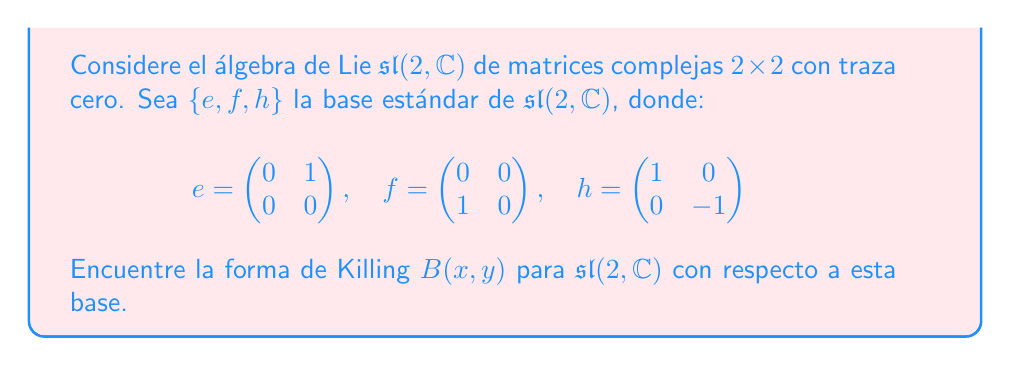Provide a solution to this math problem. Para encontrar la forma de Killing de $\mathfrak{sl}(2, \mathbb{C})$, seguiremos estos pasos:

1) La forma de Killing se define como $B(x,y) = \text{tr}(\text{ad}(x) \circ \text{ad}(y))$, donde $\text{ad}(x)$ es la representación adjunta de $x$.

2) Primero, calculemos $\text{ad}(e)$, $\text{ad}(f)$, y $\text{ad}(h)$:

   $\text{ad}(e)(e) = 0$
   $\text{ad}(e)(f) = h$
   $\text{ad}(e)(h) = -2e$

   $\text{ad}(f)(e) = -h$
   $\text{ad}(f)(f) = 0$
   $\text{ad}(f)(h) = 2f$

   $\text{ad}(h)(e) = 2e$
   $\text{ad}(h)(f) = -2f$
   $\text{ad}(h)(h) = 0$

3) Ahora, calculemos $B(x,y)$ para cada par de elementos de la base:

   $B(e,e) = \text{tr}(\text{ad}(e) \circ \text{ad}(e)) = 0$
   $B(e,f) = \text{tr}(\text{ad}(e) \circ \text{ad}(f)) = \text{tr}(\begin{pmatrix} 0 & 0 & -2 \\ 0 & 0 & 0 \\ 0 & -1 & 0 \end{pmatrix}) = 0$
   $B(e,h) = \text{tr}(\text{ad}(e) \circ \text{ad}(h)) = \text{tr}(\begin{pmatrix} 0 & 0 & -4 \\ 0 & 0 & 0 \\ 0 & 0 & 0 \end{pmatrix}) = 0$
   $B(f,f) = \text{tr}(\text{ad}(f) \circ \text{ad}(f)) = 0$
   $B(f,h) = \text{tr}(\text{ad}(f) \circ \text{ad}(h)) = \text{tr}(\begin{pmatrix} 0 & 0 & 0 \\ 0 & 0 & -4 \\ 0 & 0 & 0 \end{pmatrix}) = 0$
   $B(h,h) = \text{tr}(\text{ad}(h) \circ \text{ad}(h)) = \text{tr}(\begin{pmatrix} 4 & 0 & 0 \\ 0 & 4 & 0 \\ 0 & 0 & 0 \end{pmatrix}) = 8$

4) Por simetría, $B(f,e) = B(e,f) = 0$, $B(h,e) = B(e,h) = 0$, y $B(h,f) = B(f,h) = 0$.

5) Por lo tanto, la matriz de la forma de Killing con respecto a la base $\{e,f,h\}$ es:

   $$B = \begin{pmatrix} 0 & 0 & 0 \\ 0 & 0 & 0 \\ 0 & 0 & 8 \end{pmatrix}$$
Answer: La forma de Killing de $\mathfrak{sl}(2, \mathbb{C})$ con respecto a la base estándar $\{e,f,h\}$ es:

$$B = \begin{pmatrix} 0 & 0 & 0 \\ 0 & 0 & 0 \\ 0 & 0 & 8 \end{pmatrix}$$ 